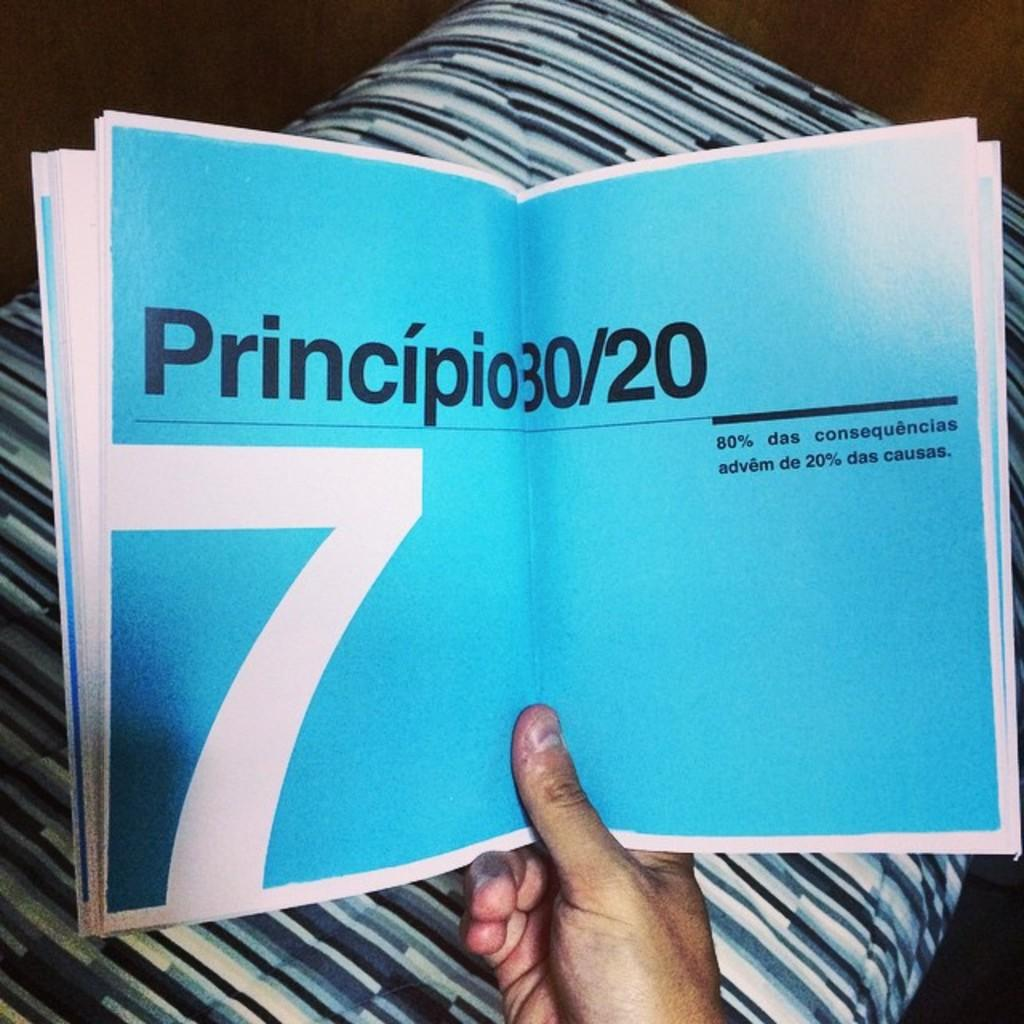<image>
Describe the image concisely. Small kind of book that says Principio 30/20. 